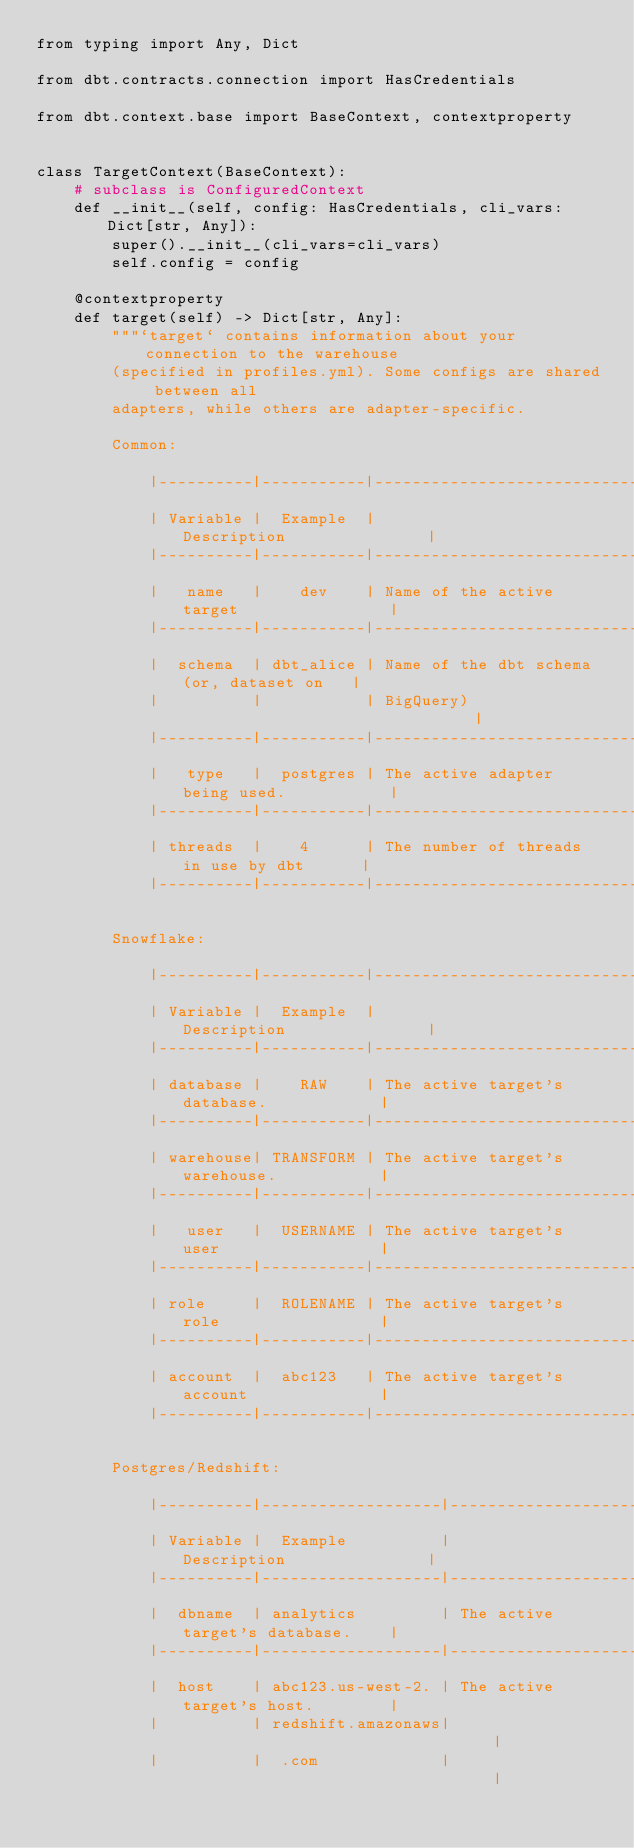<code> <loc_0><loc_0><loc_500><loc_500><_Python_>from typing import Any, Dict

from dbt.contracts.connection import HasCredentials

from dbt.context.base import BaseContext, contextproperty


class TargetContext(BaseContext):
    # subclass is ConfiguredContext
    def __init__(self, config: HasCredentials, cli_vars: Dict[str, Any]):
        super().__init__(cli_vars=cli_vars)
        self.config = config

    @contextproperty
    def target(self) -> Dict[str, Any]:
        """`target` contains information about your connection to the warehouse
        (specified in profiles.yml). Some configs are shared between all
        adapters, while others are adapter-specific.

        Common:

            |----------|-----------|------------------------------------------|
            | Variable |  Example  |                Description               |
            |----------|-----------|------------------------------------------|
            |   name   |    dev    | Name of the active target                |
            |----------|-----------|------------------------------------------|
            |  schema  | dbt_alice | Name of the dbt schema (or, dataset on   |
            |          |           | BigQuery)                                |
            |----------|-----------|------------------------------------------|
            |   type   |  postgres | The active adapter being used.           |
            |----------|-----------|------------------------------------------|
            | threads  |    4      | The number of threads in use by dbt      |
            |----------|-----------|------------------------------------------|

        Snowflake:

            |----------|-----------|------------------------------------------|
            | Variable |  Example  |                Description               |
            |----------|-----------|------------------------------------------|
            | database |    RAW    | The active target's database.            |
            |----------|-----------|------------------------------------------|
            | warehouse| TRANSFORM | The active target's warehouse.           |
            |----------|-----------|------------------------------------------|
            |   user   |  USERNAME | The active target's user                 |
            |----------|-----------|------------------------------------------|
            | role     |  ROLENAME | The active target's role                 |
            |----------|-----------|------------------------------------------|
            | account  |  abc123   | The active target's account              |
            |----------|-----------|------------------------------------------|

        Postgres/Redshift:

            |----------|-------------------|----------------------------------|
            | Variable |  Example          |        Description               |
            |----------|-------------------|----------------------------------|
            |  dbname  | analytics         | The active target's database.    |
            |----------|-------------------|----------------------------------|
            |  host    | abc123.us-west-2. | The active target's host.        |
            |          | redshift.amazonaws|                                  |
            |          |  .com             |                                  |</code> 